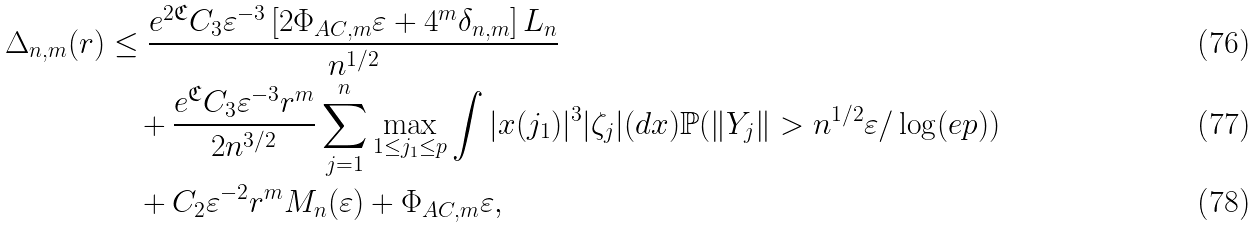Convert formula to latex. <formula><loc_0><loc_0><loc_500><loc_500>\Delta _ { n , m } ( r ) & \leq \frac { e ^ { 2 \mathfrak { C } } C _ { 3 } \varepsilon ^ { - 3 } \left [ { 2 \Phi _ { A C , m } \varepsilon } + { 4 ^ { m } \delta _ { n , m } } \right ] L _ { n } } { n ^ { 1 / 2 } } \\ & \quad + \frac { e ^ { \mathfrak { C } } C _ { 3 } \varepsilon ^ { - 3 } r ^ { m } } { 2 n ^ { 3 / 2 } } \sum _ { j = 1 } ^ { n } \max _ { 1 \leq j _ { 1 } \leq p } \int | x ( j _ { 1 } ) | ^ { 3 } | \zeta _ { j } | ( d x ) \mathbb { P } ( \| Y _ { j } \| > n ^ { 1 / 2 } \varepsilon / \log ( e p ) ) \\ & \quad + { C _ { 2 } \varepsilon ^ { - 2 } r ^ { m } } M _ { n } ( \varepsilon ) + \Phi _ { A C , m } \varepsilon ,</formula> 